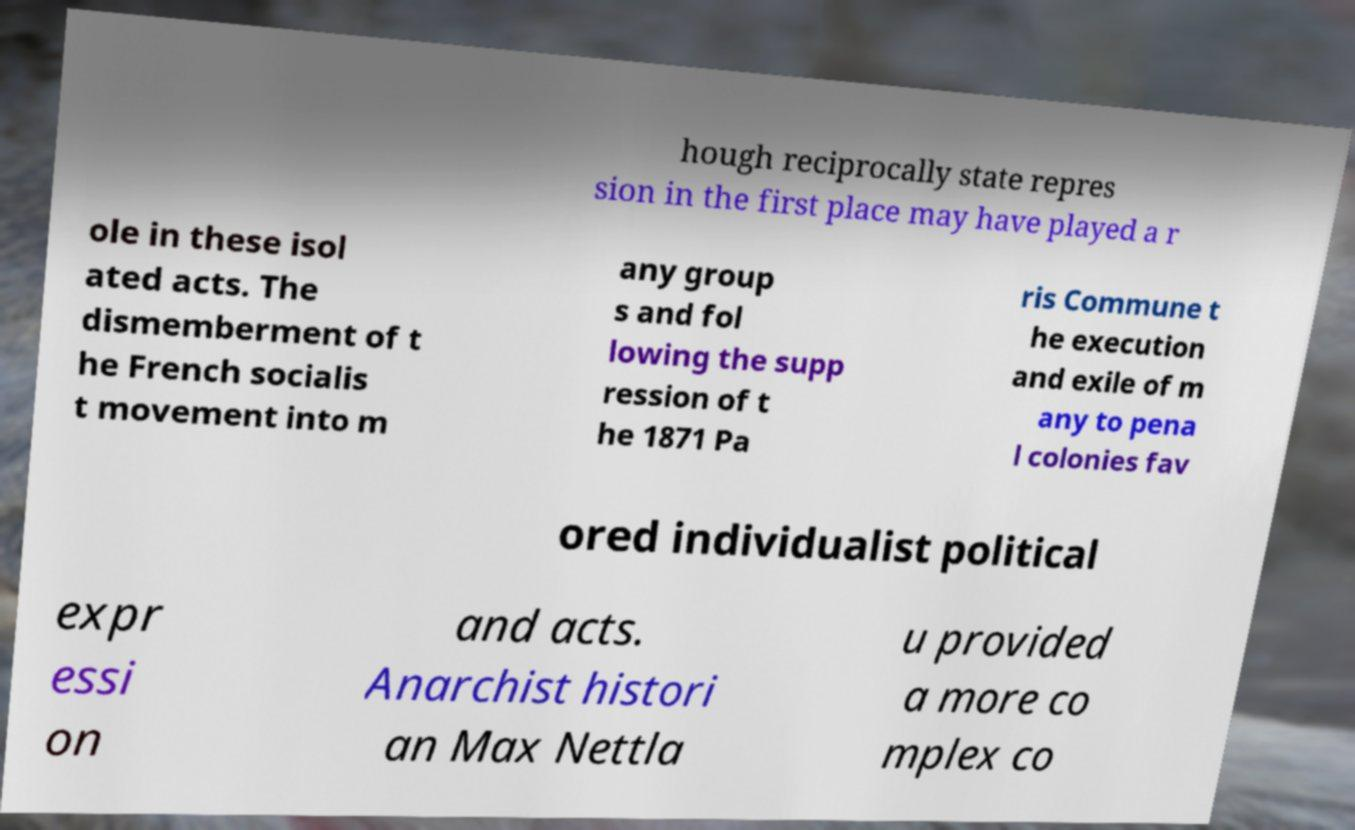Please read and relay the text visible in this image. What does it say? hough reciprocally state repres sion in the first place may have played a r ole in these isol ated acts. The dismemberment of t he French socialis t movement into m any group s and fol lowing the supp ression of t he 1871 Pa ris Commune t he execution and exile of m any to pena l colonies fav ored individualist political expr essi on and acts. Anarchist histori an Max Nettla u provided a more co mplex co 